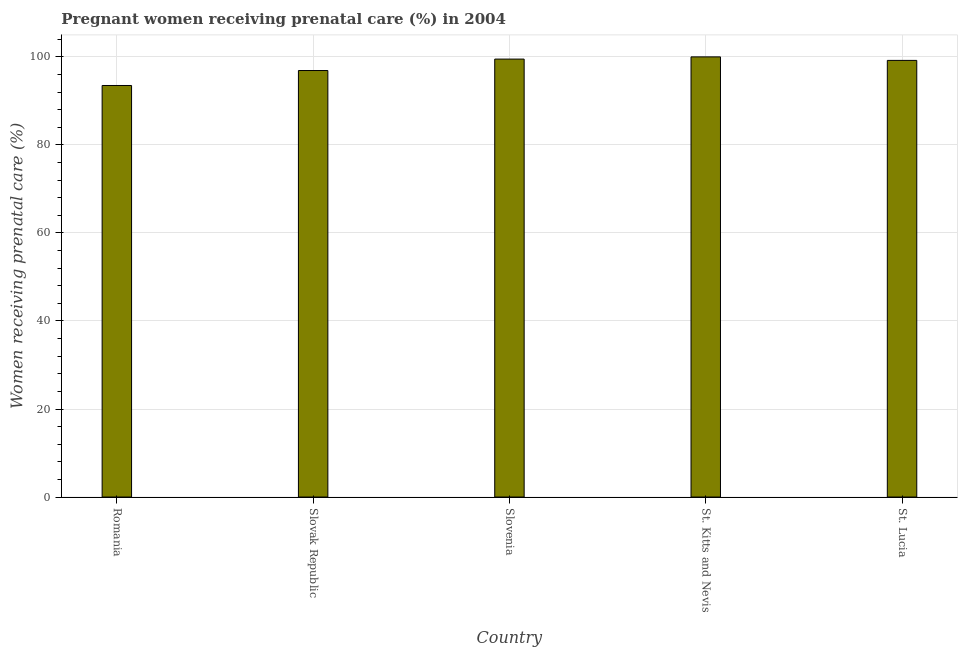Does the graph contain grids?
Your response must be concise. Yes. What is the title of the graph?
Your response must be concise. Pregnant women receiving prenatal care (%) in 2004. What is the label or title of the X-axis?
Ensure brevity in your answer.  Country. What is the label or title of the Y-axis?
Offer a terse response. Women receiving prenatal care (%). What is the percentage of pregnant women receiving prenatal care in St. Lucia?
Make the answer very short. 99.2. Across all countries, what is the minimum percentage of pregnant women receiving prenatal care?
Make the answer very short. 93.5. In which country was the percentage of pregnant women receiving prenatal care maximum?
Provide a succinct answer. St. Kitts and Nevis. In which country was the percentage of pregnant women receiving prenatal care minimum?
Your answer should be compact. Romania. What is the sum of the percentage of pregnant women receiving prenatal care?
Give a very brief answer. 489.1. What is the difference between the percentage of pregnant women receiving prenatal care in Romania and Slovak Republic?
Make the answer very short. -3.4. What is the average percentage of pregnant women receiving prenatal care per country?
Give a very brief answer. 97.82. What is the median percentage of pregnant women receiving prenatal care?
Make the answer very short. 99.2. What is the ratio of the percentage of pregnant women receiving prenatal care in St. Kitts and Nevis to that in St. Lucia?
Make the answer very short. 1.01. What is the difference between the highest and the second highest percentage of pregnant women receiving prenatal care?
Your answer should be very brief. 0.5. Is the sum of the percentage of pregnant women receiving prenatal care in St. Kitts and Nevis and St. Lucia greater than the maximum percentage of pregnant women receiving prenatal care across all countries?
Offer a very short reply. Yes. What is the difference between the highest and the lowest percentage of pregnant women receiving prenatal care?
Offer a terse response. 6.5. How many countries are there in the graph?
Provide a succinct answer. 5. What is the difference between two consecutive major ticks on the Y-axis?
Keep it short and to the point. 20. What is the Women receiving prenatal care (%) in Romania?
Ensure brevity in your answer.  93.5. What is the Women receiving prenatal care (%) in Slovak Republic?
Keep it short and to the point. 96.9. What is the Women receiving prenatal care (%) of Slovenia?
Provide a succinct answer. 99.5. What is the Women receiving prenatal care (%) in St. Kitts and Nevis?
Give a very brief answer. 100. What is the Women receiving prenatal care (%) of St. Lucia?
Provide a short and direct response. 99.2. What is the difference between the Women receiving prenatal care (%) in Romania and Slovak Republic?
Give a very brief answer. -3.4. What is the difference between the Women receiving prenatal care (%) in Romania and Slovenia?
Make the answer very short. -6. What is the difference between the Women receiving prenatal care (%) in Romania and St. Kitts and Nevis?
Offer a very short reply. -6.5. What is the difference between the Women receiving prenatal care (%) in Romania and St. Lucia?
Give a very brief answer. -5.7. What is the difference between the Women receiving prenatal care (%) in Slovak Republic and St. Kitts and Nevis?
Your answer should be very brief. -3.1. What is the difference between the Women receiving prenatal care (%) in Slovak Republic and St. Lucia?
Your answer should be very brief. -2.3. What is the difference between the Women receiving prenatal care (%) in St. Kitts and Nevis and St. Lucia?
Make the answer very short. 0.8. What is the ratio of the Women receiving prenatal care (%) in Romania to that in St. Kitts and Nevis?
Offer a terse response. 0.94. What is the ratio of the Women receiving prenatal care (%) in Romania to that in St. Lucia?
Provide a short and direct response. 0.94. What is the ratio of the Women receiving prenatal care (%) in Slovak Republic to that in Slovenia?
Make the answer very short. 0.97. What is the ratio of the Women receiving prenatal care (%) in Slovak Republic to that in St. Lucia?
Keep it short and to the point. 0.98. What is the ratio of the Women receiving prenatal care (%) in Slovenia to that in St. Lucia?
Your answer should be very brief. 1. What is the ratio of the Women receiving prenatal care (%) in St. Kitts and Nevis to that in St. Lucia?
Keep it short and to the point. 1.01. 